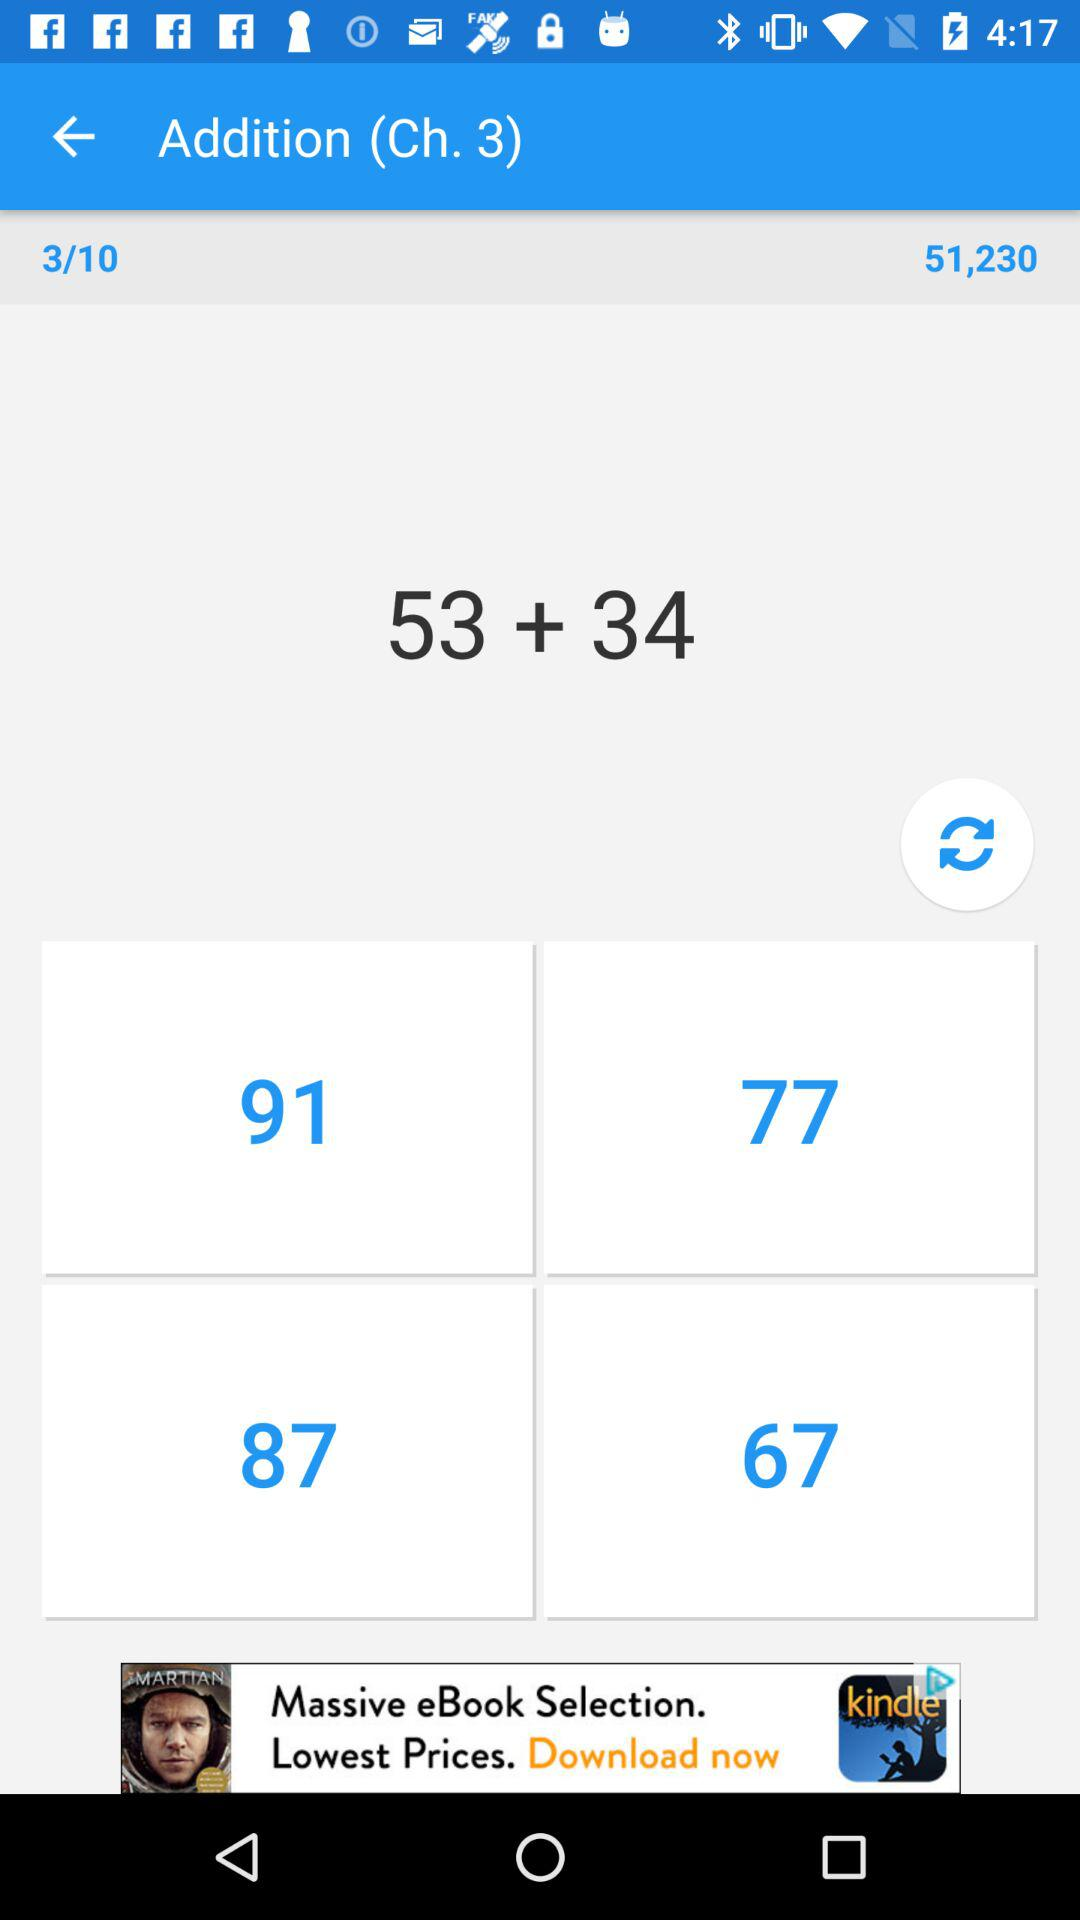How many chapters in total are there? There are 10 chapters in total. 